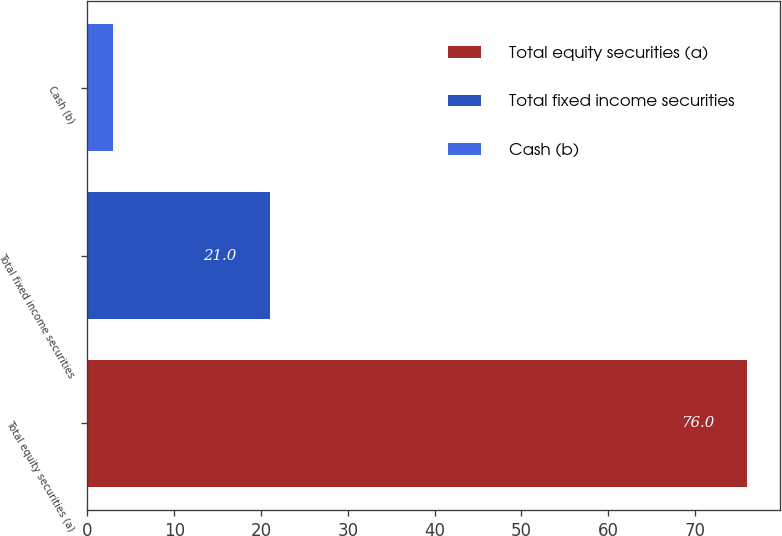<chart> <loc_0><loc_0><loc_500><loc_500><bar_chart><fcel>Total equity securities (a)<fcel>Total fixed income securities<fcel>Cash (b)<nl><fcel>76<fcel>21<fcel>3<nl></chart> 